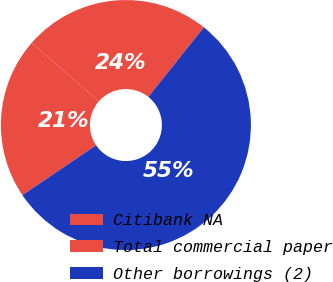Convert chart. <chart><loc_0><loc_0><loc_500><loc_500><pie_chart><fcel>Citibank NA<fcel>Total commercial paper<fcel>Other borrowings (2)<nl><fcel>20.9%<fcel>24.29%<fcel>54.81%<nl></chart> 